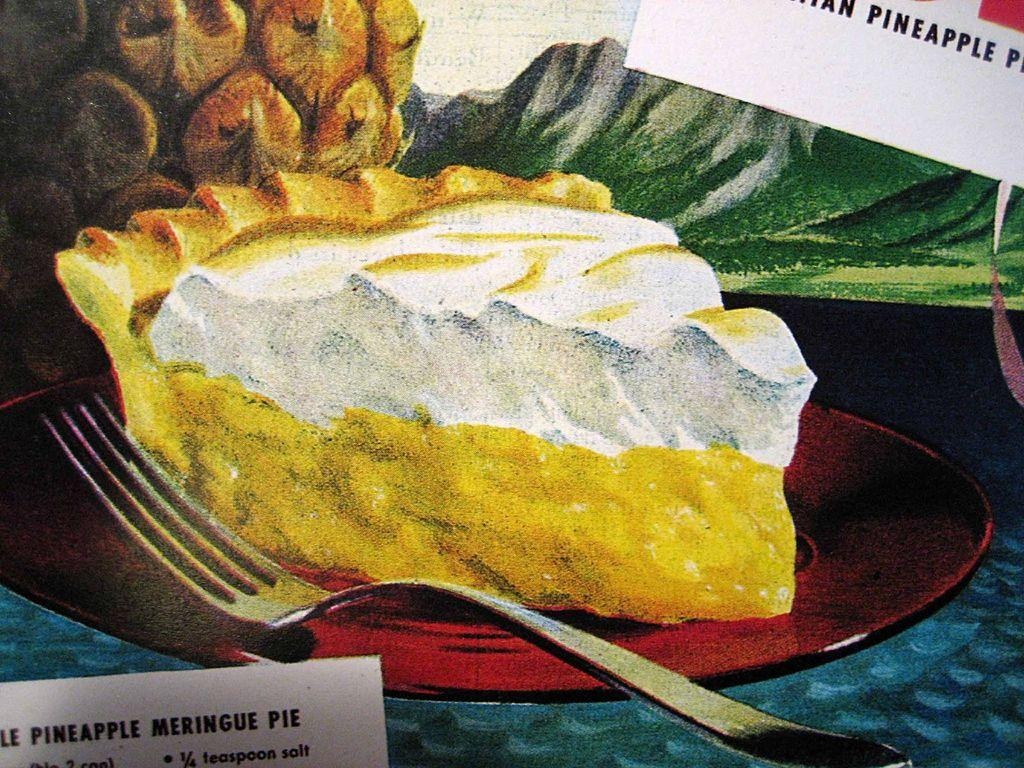What type of food item is depicted in the painting? There is a food item in the painting, but the specific type is not mentioned in the facts. What is placed on the plate in the painting? There is a fork on a plate in the painting. What fruit is present in the painting? There is a pineapple in the painting. What natural element is visible in the painting? Water is visible in the painting. What geographical feature is present in the painting? There are hills in the painting. What part of the sky is visible in the painting? The sky is visible in the painting. What type of paper is present in the painting? There are name papers in the painting. What type of juice is being served at the airport in the painting? There is no airport or juice present in the painting; it features a food item, a fork on a plate, a pineapple, water, hills, sky, and name papers. 